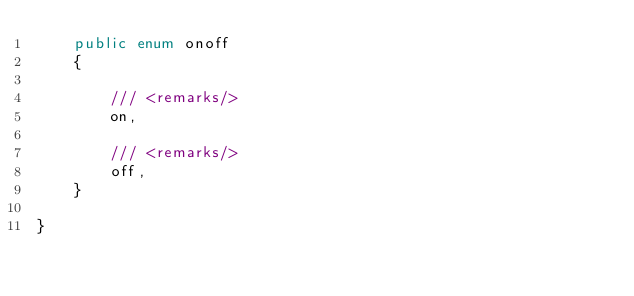<code> <loc_0><loc_0><loc_500><loc_500><_C#_>    public enum onoff
    {

        /// <remarks/>
        on,

        /// <remarks/>
        off,
    }

}</code> 